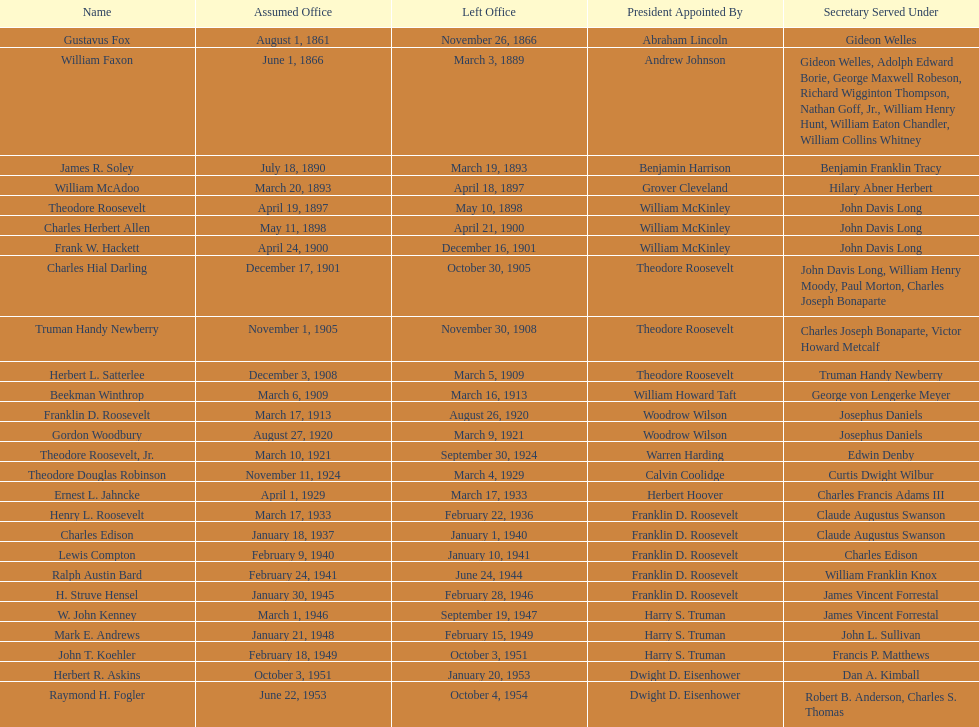Who held the position of first assistant secretary of the navy? Gustavus Fox. 